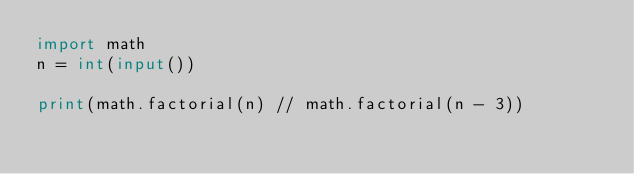Convert code to text. <code><loc_0><loc_0><loc_500><loc_500><_Python_>import math
n = int(input())
 
print(math.factorial(n) // math.factorial(n - 3))</code> 